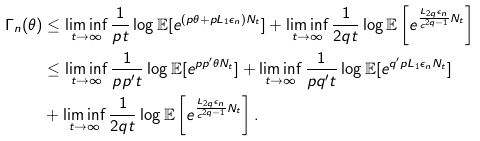<formula> <loc_0><loc_0><loc_500><loc_500>\Gamma _ { n } ( \theta ) & \leq \liminf _ { t \rightarrow \infty } \frac { 1 } { p t } \log \mathbb { E } [ e ^ { ( p \theta + p L _ { 1 } \epsilon _ { n } ) N _ { t } } ] + \liminf _ { t \rightarrow \infty } \frac { 1 } { 2 q t } \log \mathbb { E } \left [ e ^ { \frac { L _ { 2 q } \epsilon _ { n } } { c ^ { 2 q - 1 } } N _ { t } } \right ] \\ & \leq \liminf _ { t \rightarrow \infty } \frac { 1 } { p p ^ { \prime } t } \log \mathbb { E } [ e ^ { p p ^ { \prime } \theta N _ { t } } ] + \liminf _ { t \rightarrow \infty } \frac { 1 } { p q ^ { \prime } t } \log \mathbb { E } [ e ^ { q ^ { \prime } p L _ { 1 } \epsilon _ { n } N _ { t } } ] \\ & + \liminf _ { t \rightarrow \infty } \frac { 1 } { 2 q t } \log \mathbb { E } \left [ e ^ { \frac { L _ { 2 q } \epsilon _ { n } } { c ^ { 2 q - 1 } } N _ { t } } \right ] .</formula> 